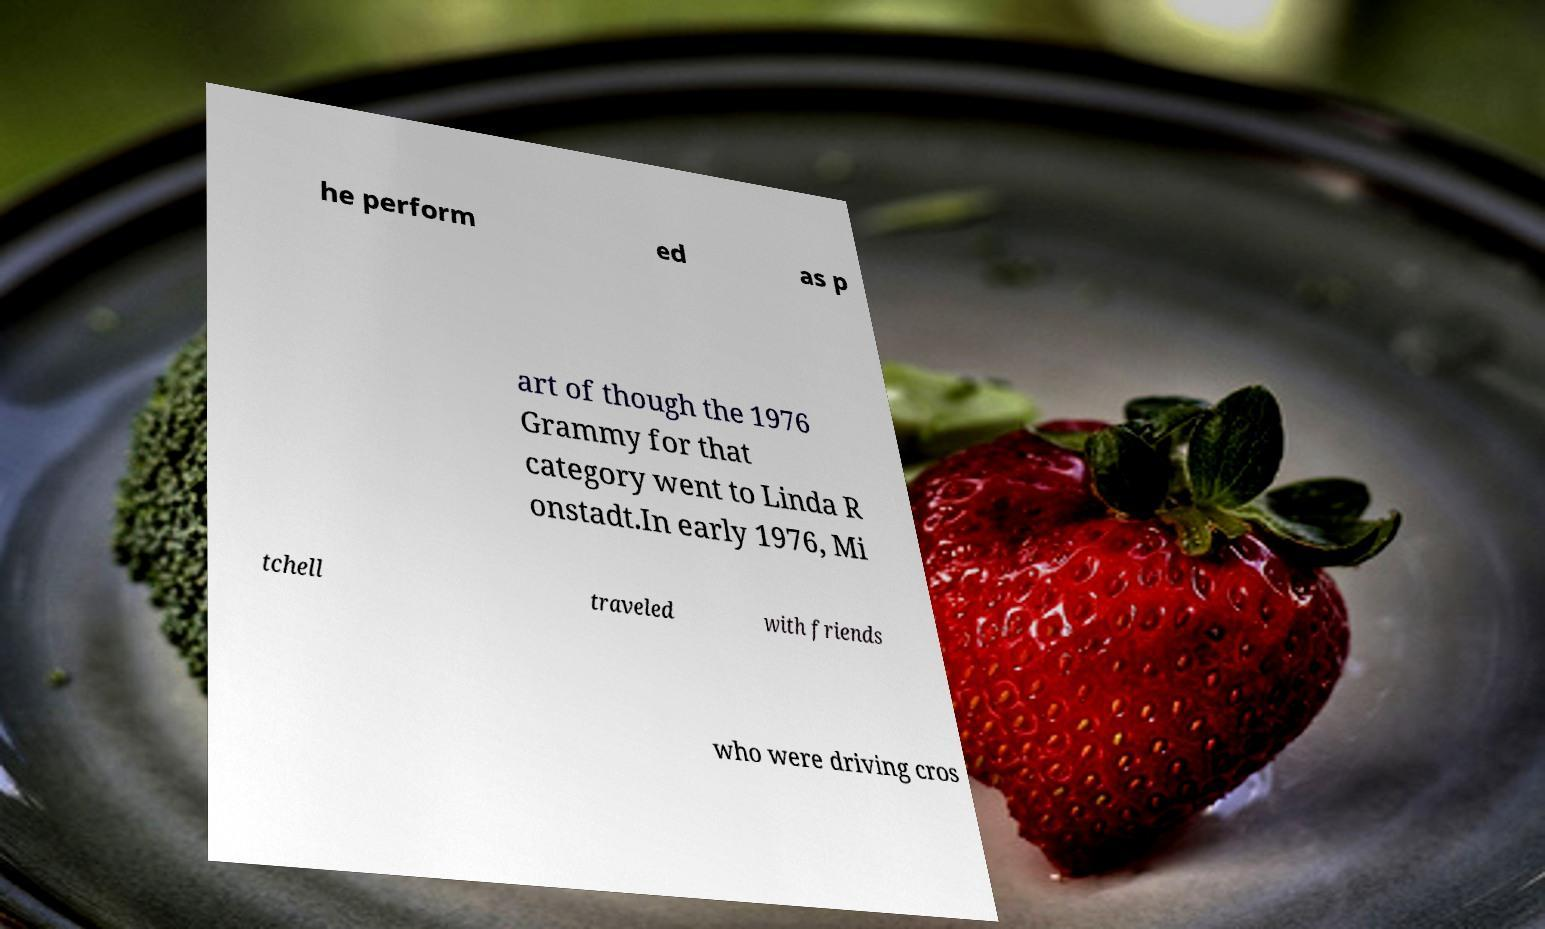I need the written content from this picture converted into text. Can you do that? he perform ed as p art of though the 1976 Grammy for that category went to Linda R onstadt.In early 1976, Mi tchell traveled with friends who were driving cros 